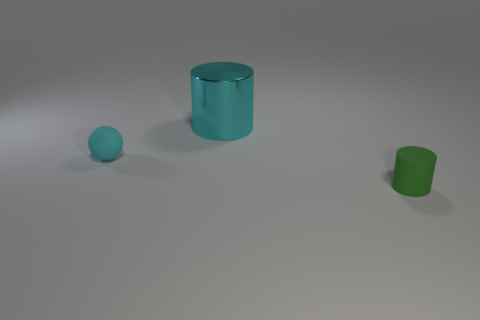Add 3 cyan rubber things. How many objects exist? 6 Subtract all cylinders. How many objects are left? 1 Add 3 big cyan cylinders. How many big cyan cylinders exist? 4 Subtract all green cylinders. How many cylinders are left? 1 Subtract 0 gray cylinders. How many objects are left? 3 Subtract 1 spheres. How many spheres are left? 0 Subtract all yellow cylinders. Subtract all gray spheres. How many cylinders are left? 2 Subtract all blue cylinders. How many yellow balls are left? 0 Subtract all small brown metal balls. Subtract all matte cylinders. How many objects are left? 2 Add 3 cyan matte objects. How many cyan matte objects are left? 4 